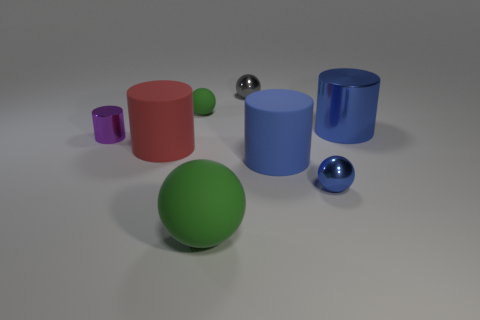How many blue cylinders must be subtracted to get 1 blue cylinders? 1 Subtract 1 cylinders. How many cylinders are left? 3 Add 1 big blue things. How many objects exist? 9 Add 2 blue rubber things. How many blue rubber things exist? 3 Subtract 0 red cubes. How many objects are left? 8 Subtract all blue rubber cylinders. Subtract all red cylinders. How many objects are left? 6 Add 8 gray metal objects. How many gray metal objects are left? 9 